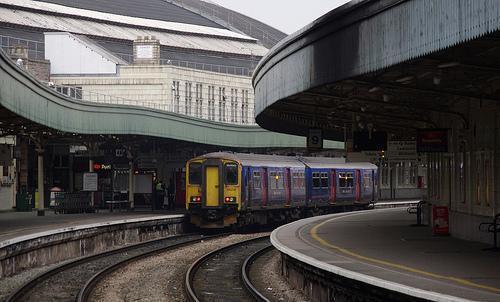How many trains are there?
Give a very brief answer. 1. 